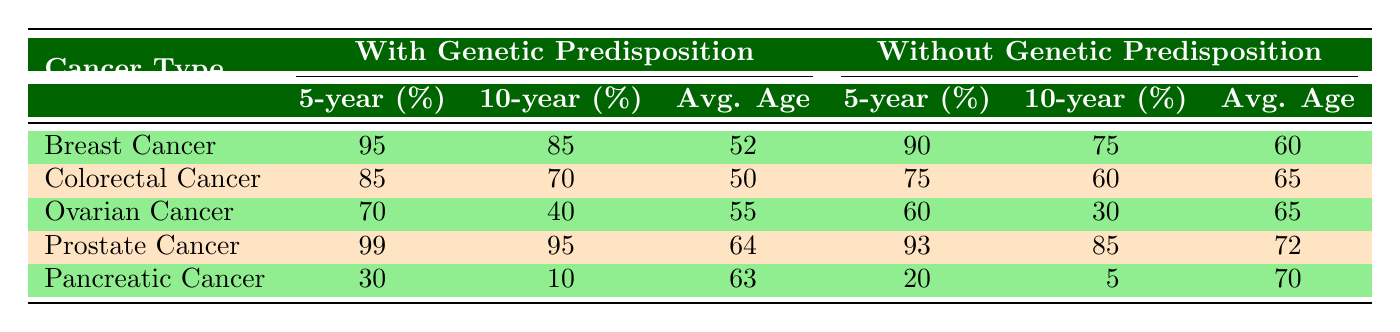What is the 5-year survival rate for ovarian cancer patients with genetic predisposition? The table shows that the 5-year survival rate for ovarian cancer patients with genetic predisposition is listed under the relevant column, which states it is 70%.
Answer: 70% What is the average age at diagnosis for colorectal cancer patients without genetic predisposition? The average age at diagnosis for colorectal cancer patients without genetic predisposition is found in the last column of the relevant row, which states it is 65 years.
Answer: 65 Does breast cancer have a higher 10-year survival rate for patients with genetic predisposition compared to those without? To determine this, we look at the 10-year survival rates for breast cancer: 85% for those with genetic predisposition and 75% for those without. Since 85% is greater than 75%, the answer is yes.
Answer: Yes What is the difference in 5-year survival rates between prostate cancer patients with and without genetic predisposition? The 5-year survival rate for prostate cancer patients with genetic predisposition is 99%, and for those without it is 93%. The difference is calculated as 99% - 93% = 6%.
Answer: 6% What is the average of the 10-year survival rates for patients with genetic predisposition across all cancer types listed? We sum up the 10-year survival rates for genetic predisposition: 85 (Breast) + 70 (Colorectal) + 40 (Ovarian) + 95 (Prostate) + 10 (Pancreatic) = 300. There are 5 cancer types, so the average is 300 / 5 = 60%.
Answer: 60% 